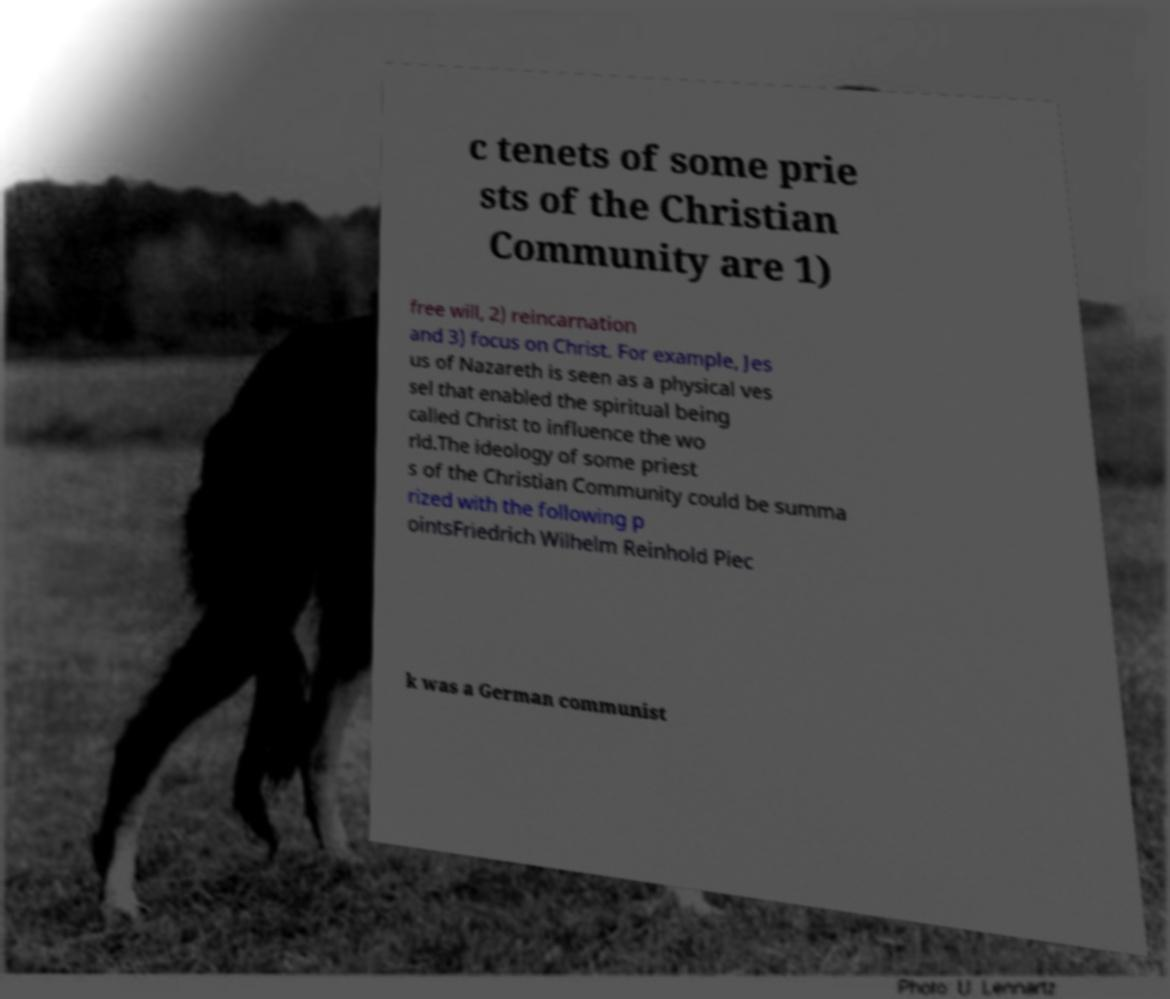Please read and relay the text visible in this image. What does it say? c tenets of some prie sts of the Christian Community are 1) free will, 2) reincarnation and 3) focus on Christ. For example, Jes us of Nazareth is seen as a physical ves sel that enabled the spiritual being called Christ to influence the wo rld.The ideology of some priest s of the Christian Community could be summa rized with the following p ointsFriedrich Wilhelm Reinhold Piec k was a German communist 